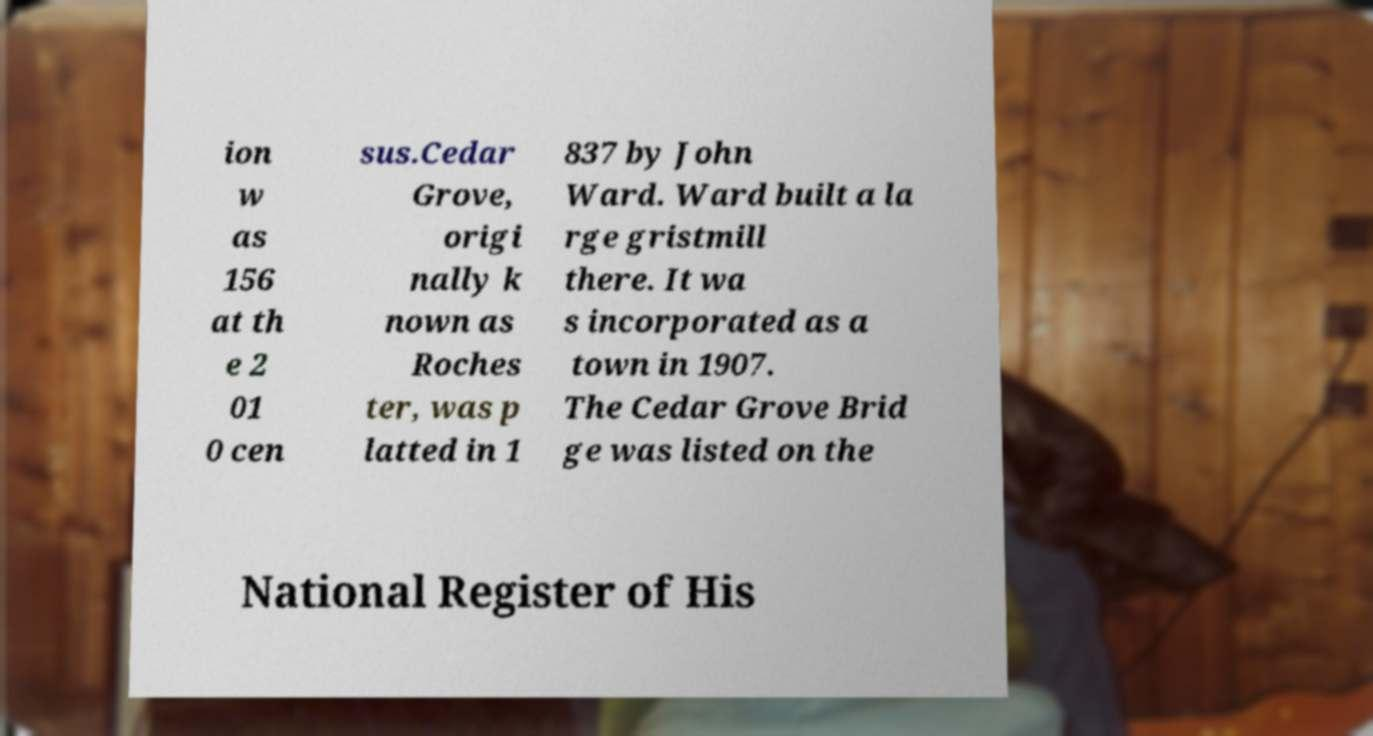What messages or text are displayed in this image? I need them in a readable, typed format. ion w as 156 at th e 2 01 0 cen sus.Cedar Grove, origi nally k nown as Roches ter, was p latted in 1 837 by John Ward. Ward built a la rge gristmill there. It wa s incorporated as a town in 1907. The Cedar Grove Brid ge was listed on the National Register of His 